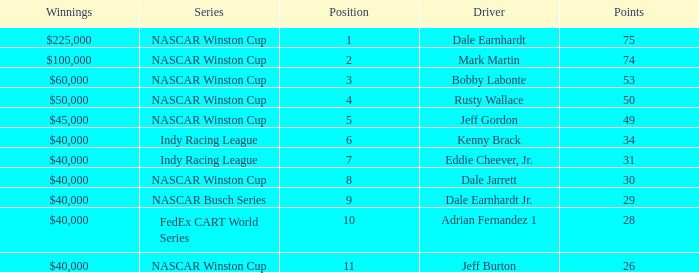In what position was the driver who won $60,000? 3.0. 